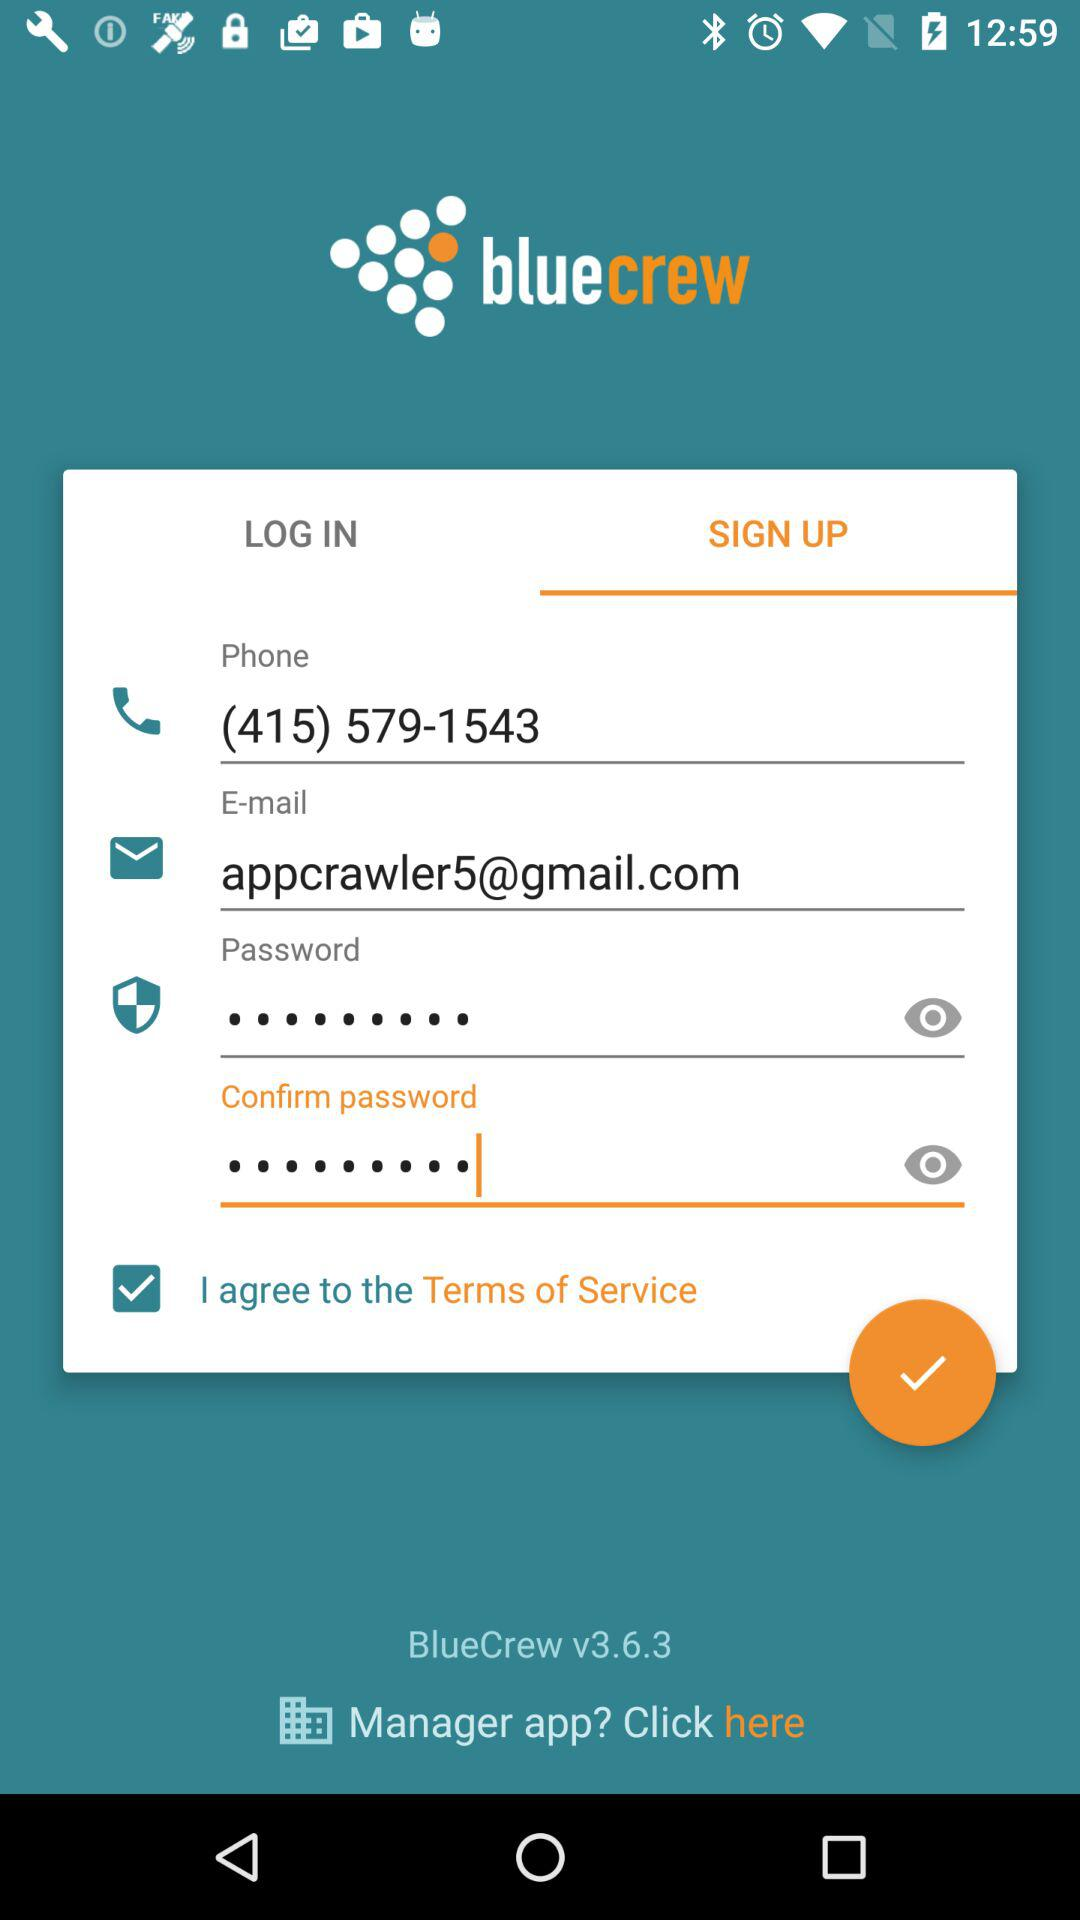How many text inputs have a hint?
Answer the question using a single word or phrase. 2 